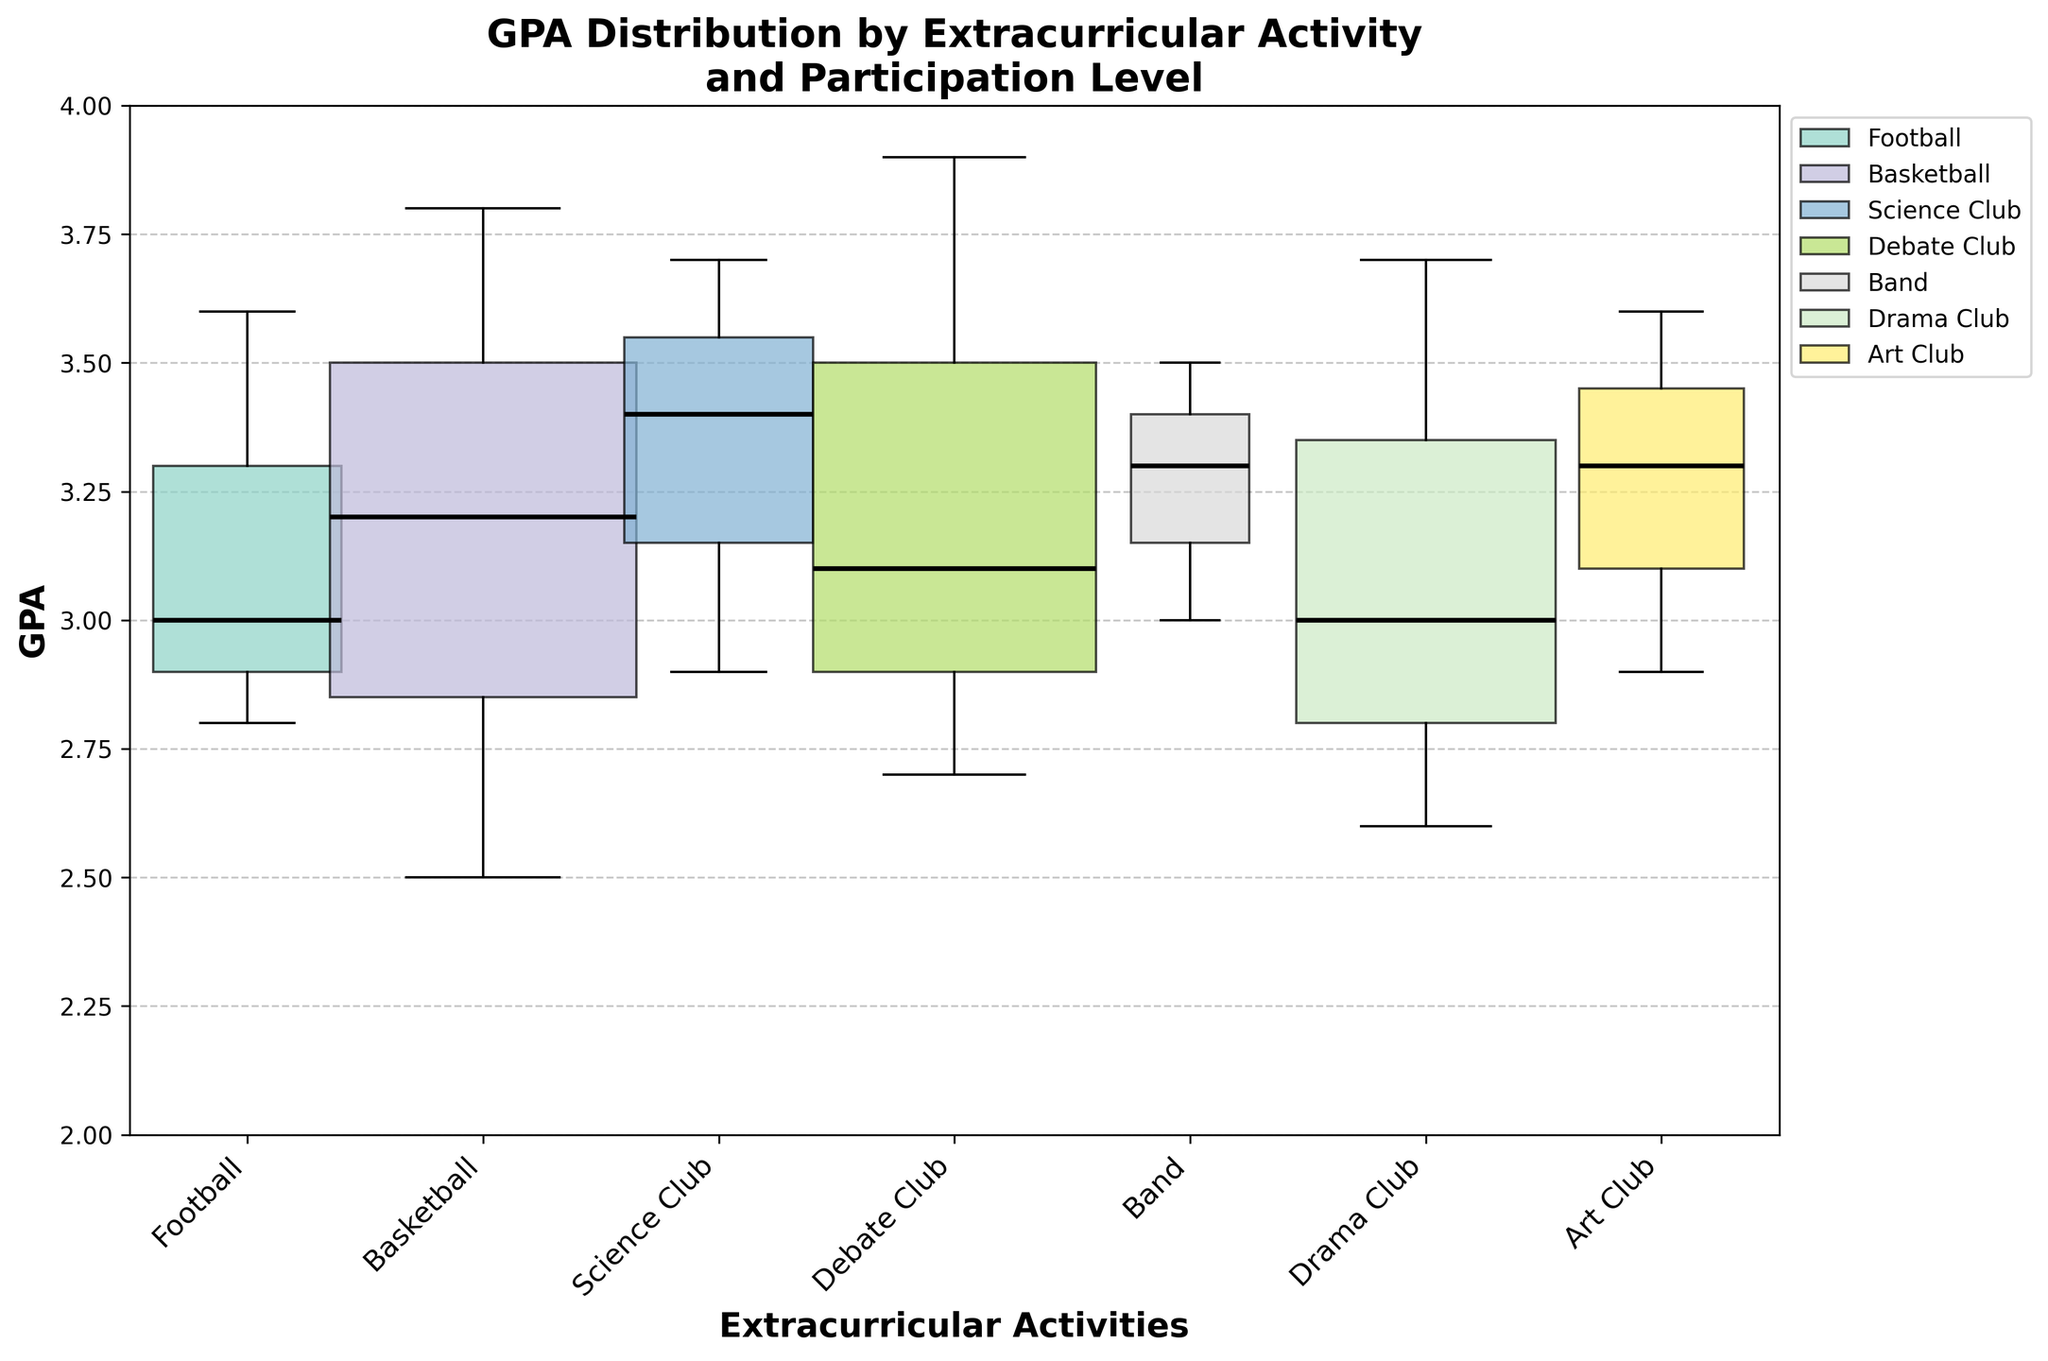What is the title of the figure? The title of the figure is located at the top of the plot and provides an overview of the content shown in the figure.
Answer: GPA Distribution by Extracurricular Activity and Participation Level Which extracurricular activity has the highest GPA variability? GPA variability can be determined by the width of the box plots, with wider boxes indicating greater variability.
Answer: Debate Club What is the GPA range for students with low participation in Football? The GPA range for low participation in Football can be identified by looking at the box plot representing Football and noting the low participation point.
Answer: 2.8 What is the median GPA for students in Basketball? The median GPA is represented by the black line within the box; identify the box plot for Basketball and find the median line.
Answer: Medium participation: 3.2 Which activity has the smallest difference in GPA between low and high participation? The smallest difference in GPA between low and high participation is represented by the narrowest box plot width for an activity.
Answer: Band How does the GPA for high participation in Art Club compare to high participation in Drama Club? Compare the position of the high participation point for Art Club with the high participation point for Drama Club on the GPA scale.
Answer: Art Club GPA is slightly higher What's the difference in GPA between low and high participation in Science Club? Calculate the difference by subtracting the GPA of low participation from the GPA of high participation for Science Club.
Answer: 0.8 Which activity shows the least improvement in GPA from low to medium participation? This is identified by the shortest distance between low and medium participation points within an activity's box plot.
Answer: Debate Club What are the GPA ranges for all participation levels in Art Club? Identify and list the GPA values for low, medium, and high participation in Art Club from the respective box plot.
Answer: Low: 2.9, Medium: 3.3, High: 3.6 Compare the median GPA of students in Drama Club with medium participation to those with medium participation in Football. Which is higher? Locate the black median line within the box plots for Drama Club and Football and compare their positions.
Answer: Football 